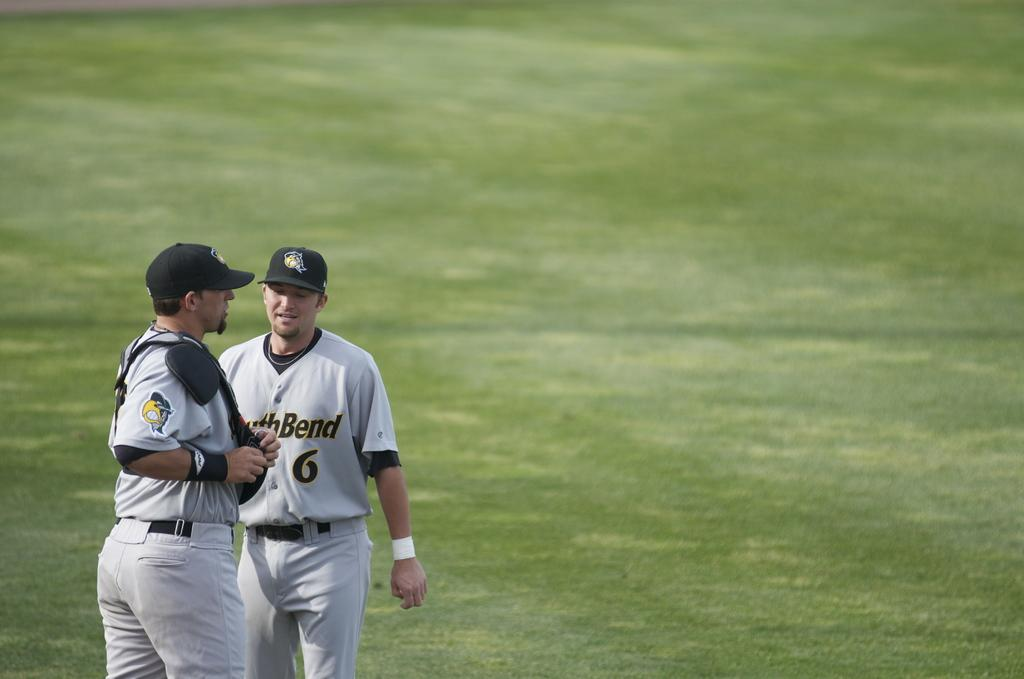<image>
Describe the image concisely. One of the players on the pitch is wearing a number 6 on their top. 